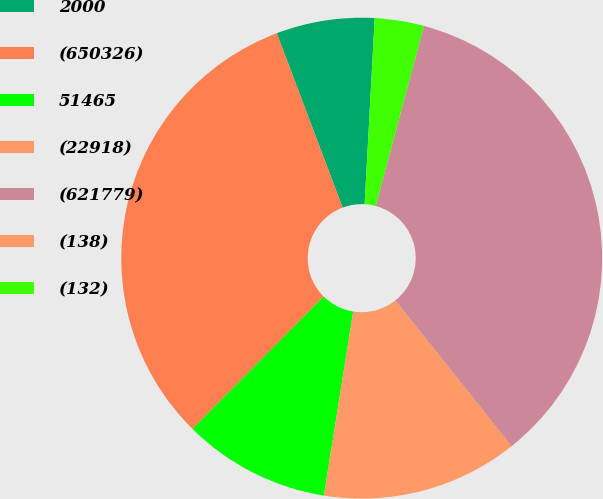Convert chart. <chart><loc_0><loc_0><loc_500><loc_500><pie_chart><fcel>2000<fcel>(650326)<fcel>51465<fcel>(22918)<fcel>(621779)<fcel>(138)<fcel>(132)<nl><fcel>6.61%<fcel>31.82%<fcel>9.92%<fcel>13.22%<fcel>35.12%<fcel>0.0%<fcel>3.31%<nl></chart> 